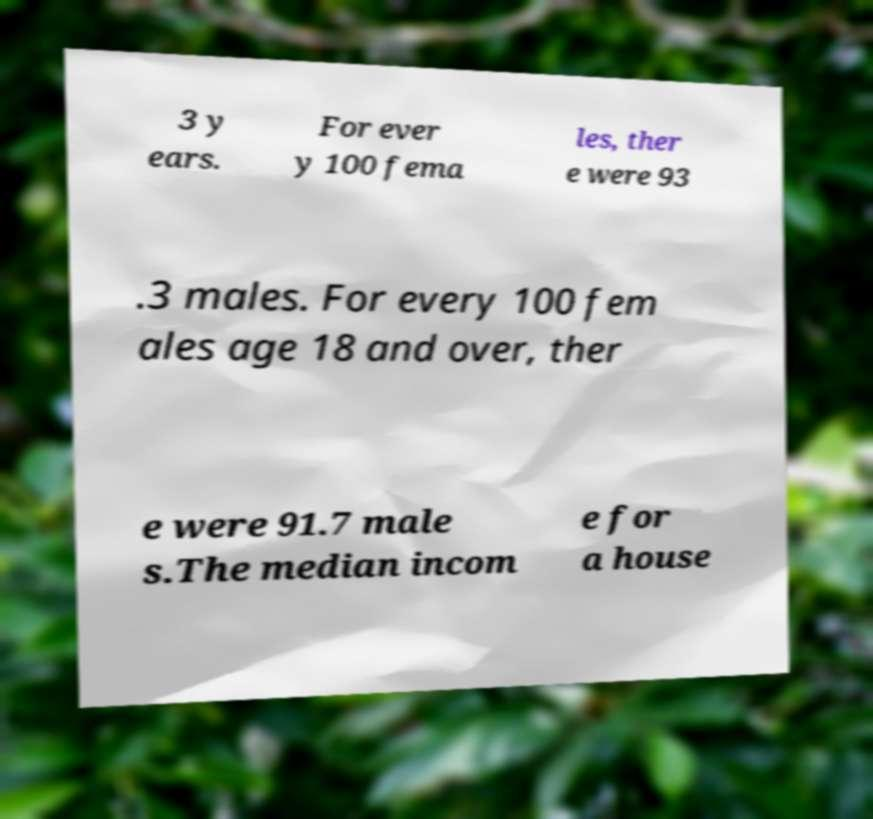Please read and relay the text visible in this image. What does it say? 3 y ears. For ever y 100 fema les, ther e were 93 .3 males. For every 100 fem ales age 18 and over, ther e were 91.7 male s.The median incom e for a house 